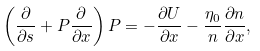Convert formula to latex. <formula><loc_0><loc_0><loc_500><loc_500>\left ( { \frac { \partial } { \partial s } } + P { \frac { \partial } { \partial x } } \right ) P = - { \frac { \partial U } { \partial x } } - { \frac { \eta _ { 0 } } { n } } { \frac { \partial n } { \partial x } } ,</formula> 